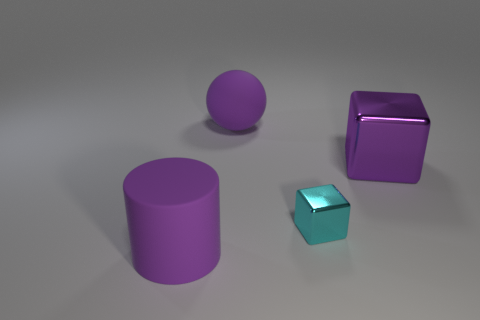Add 1 big purple matte objects. How many objects exist? 5 Subtract all cylinders. How many objects are left? 3 Subtract all big cylinders. Subtract all red shiny cylinders. How many objects are left? 3 Add 1 cyan things. How many cyan things are left? 2 Add 3 tiny yellow metal blocks. How many tiny yellow metal blocks exist? 3 Subtract 0 red balls. How many objects are left? 4 